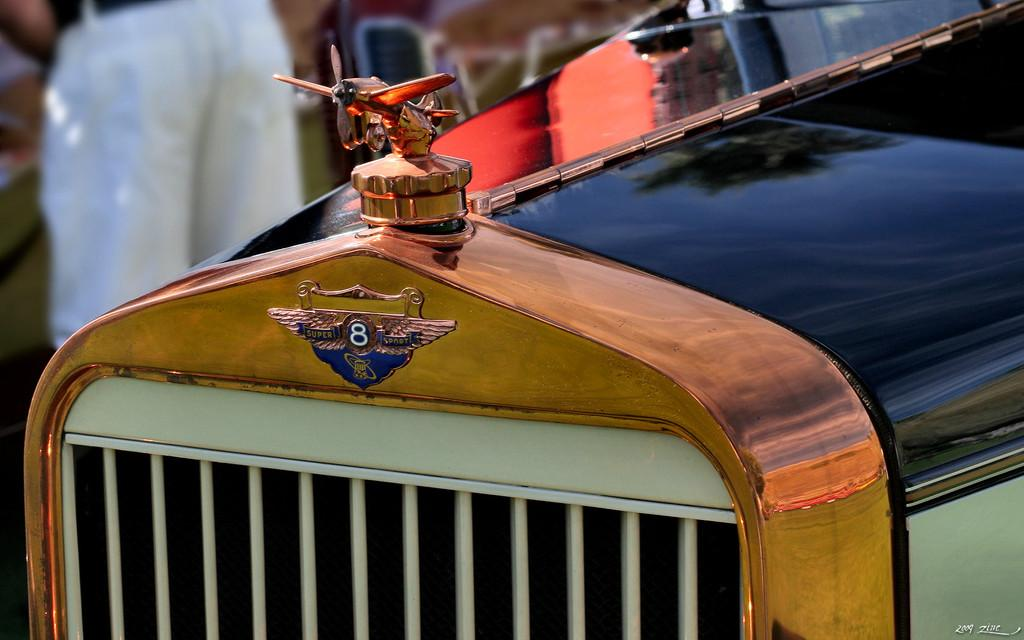What is the main subject of the image? The main subject of the image is a vehicle. What distinguishing feature can be seen on the front of the vehicle? The vehicle has an icon of a plane in the front. How is the background of the image depicted? The background of the vehicle is blurred. What type of statement can be seen written on the side of the vehicle? There is no statement visible on the side of the vehicle in the image. How many men are present in the image? There are no men present in the image; it only features a vehicle. 